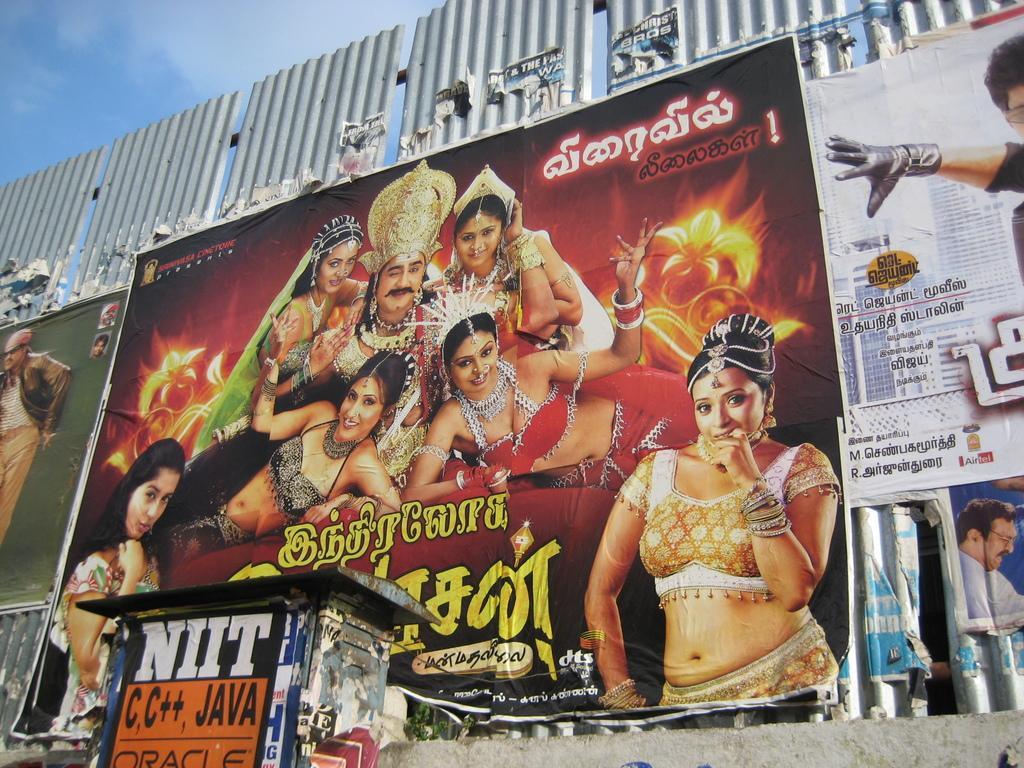Could you give a brief overview of what you see in this image? In this image I can see a poster attached to some object, in the poster I can see few persons some are sitting and some are standing. I can also see something written on the poster, background I can see sky in white and blue color. 